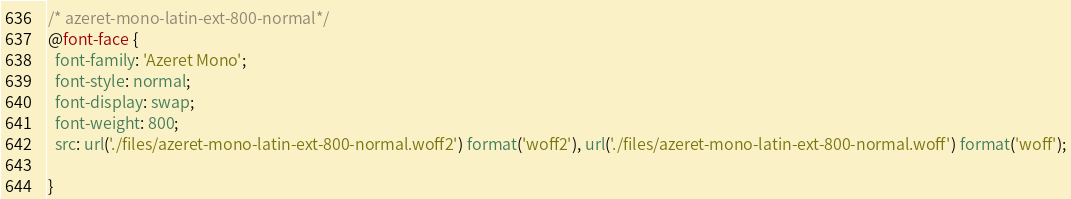Convert code to text. <code><loc_0><loc_0><loc_500><loc_500><_CSS_>/* azeret-mono-latin-ext-800-normal*/
@font-face {
  font-family: 'Azeret Mono';
  font-style: normal;
  font-display: swap;
  font-weight: 800;
  src: url('./files/azeret-mono-latin-ext-800-normal.woff2') format('woff2'), url('./files/azeret-mono-latin-ext-800-normal.woff') format('woff');
  
}
</code> 